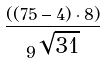<formula> <loc_0><loc_0><loc_500><loc_500>\frac { ( ( 7 5 - 4 ) \cdot 8 ) } { 9 ^ { \sqrt { 3 1 } } }</formula> 